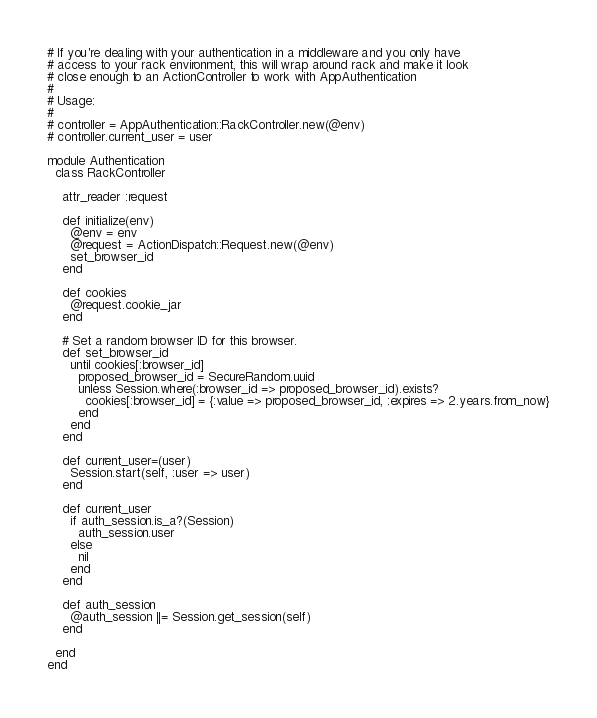<code> <loc_0><loc_0><loc_500><loc_500><_Ruby_># If you're dealing with your authentication in a middleware and you only have
# access to your rack environment, this will wrap around rack and make it look
# close enough to an ActionController to work with AppAuthentication
#
# Usage:
#
# controller = AppAuthentication::RackController.new(@env)
# controller.current_user = user

module Authentication
  class RackController

    attr_reader :request

    def initialize(env)
      @env = env
      @request = ActionDispatch::Request.new(@env)
      set_browser_id
    end

    def cookies
      @request.cookie_jar
    end

    # Set a random browser ID for this browser.
    def set_browser_id
      until cookies[:browser_id]
        proposed_browser_id = SecureRandom.uuid
        unless Session.where(:browser_id => proposed_browser_id).exists?
          cookies[:browser_id] = {:value => proposed_browser_id, :expires => 2.years.from_now}
        end
      end
    end

    def current_user=(user)
      Session.start(self, :user => user)
    end

    def current_user
      if auth_session.is_a?(Session)
        auth_session.user
      else
        nil
      end
    end

    def auth_session
      @auth_session ||= Session.get_session(self)
    end

  end
end
</code> 